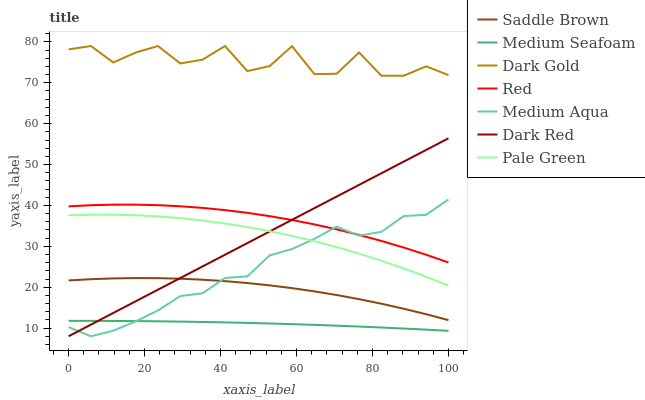Does Medium Seafoam have the minimum area under the curve?
Answer yes or no. Yes. Does Dark Gold have the maximum area under the curve?
Answer yes or no. Yes. Does Dark Red have the minimum area under the curve?
Answer yes or no. No. Does Dark Red have the maximum area under the curve?
Answer yes or no. No. Is Dark Red the smoothest?
Answer yes or no. Yes. Is Dark Gold the roughest?
Answer yes or no. Yes. Is Medium Seafoam the smoothest?
Answer yes or no. No. Is Medium Seafoam the roughest?
Answer yes or no. No. Does Dark Red have the lowest value?
Answer yes or no. Yes. Does Medium Seafoam have the lowest value?
Answer yes or no. No. Does Dark Gold have the highest value?
Answer yes or no. Yes. Does Dark Red have the highest value?
Answer yes or no. No. Is Red less than Dark Gold?
Answer yes or no. Yes. Is Red greater than Saddle Brown?
Answer yes or no. Yes. Does Medium Aqua intersect Medium Seafoam?
Answer yes or no. Yes. Is Medium Aqua less than Medium Seafoam?
Answer yes or no. No. Is Medium Aqua greater than Medium Seafoam?
Answer yes or no. No. Does Red intersect Dark Gold?
Answer yes or no. No. 